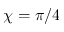<formula> <loc_0><loc_0><loc_500><loc_500>\chi = \pi / 4</formula> 